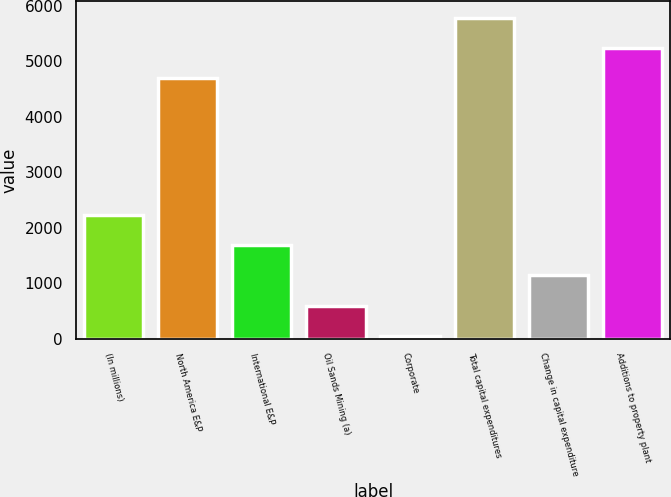<chart> <loc_0><loc_0><loc_500><loc_500><bar_chart><fcel>(In millions)<fcel>North America E&P<fcel>International E&P<fcel>Oil Sands Mining (a)<fcel>Corporate<fcel>Total capital expenditures<fcel>Change in capital expenditure<fcel>Additions to property plant<nl><fcel>2228.6<fcel>4698<fcel>1684.2<fcel>595.4<fcel>51<fcel>5786.8<fcel>1139.8<fcel>5242.4<nl></chart> 